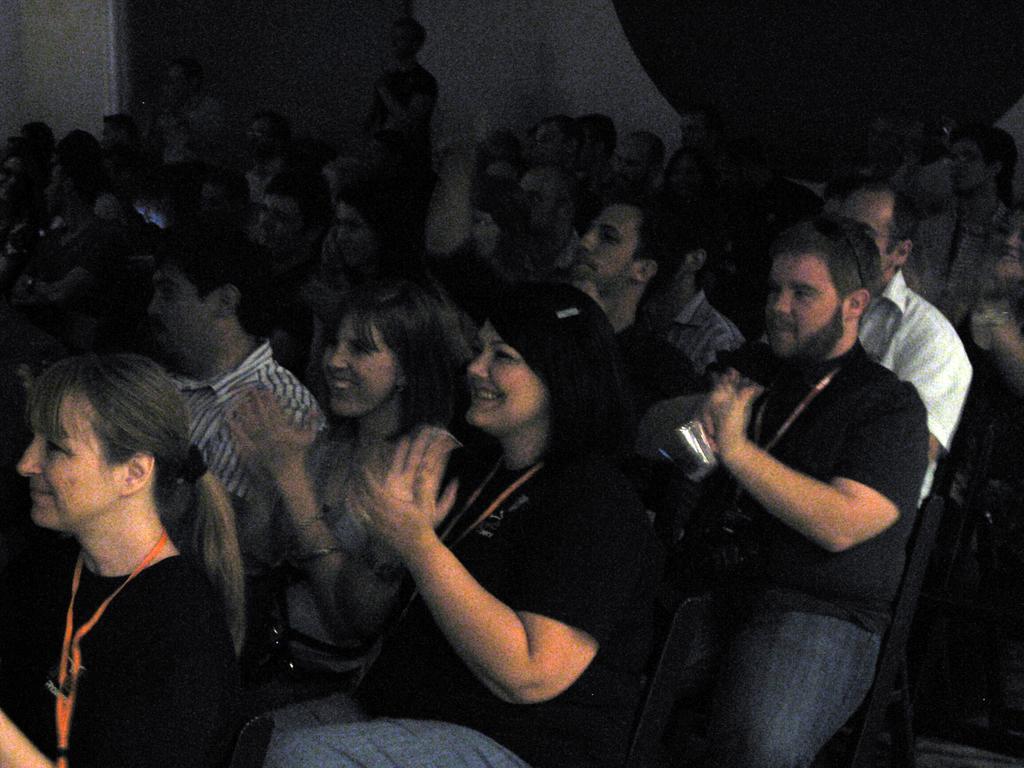Please provide a concise description of this image. As we can see in the image there are group of people sitting on chairs. In the background there is a wall. The background is dark. 